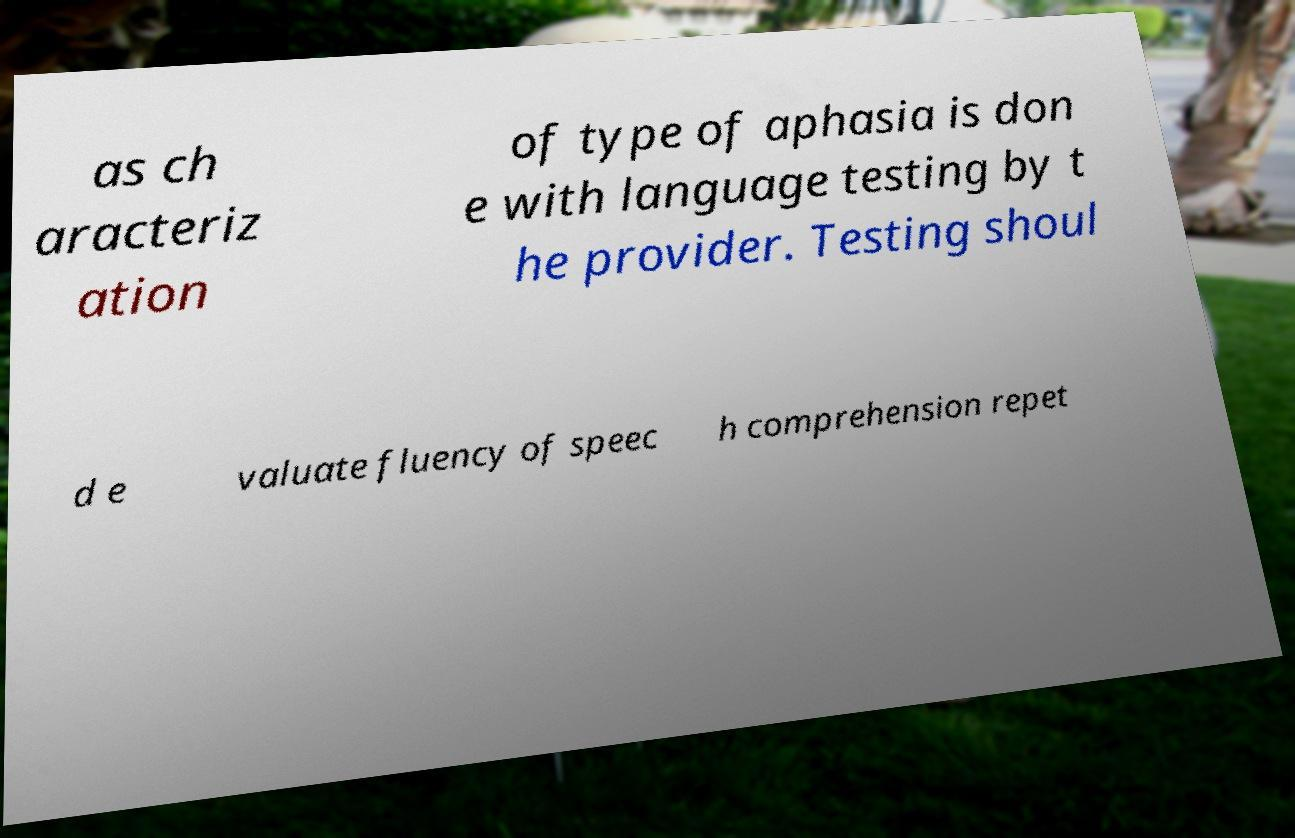Please read and relay the text visible in this image. What does it say? as ch aracteriz ation of type of aphasia is don e with language testing by t he provider. Testing shoul d e valuate fluency of speec h comprehension repet 